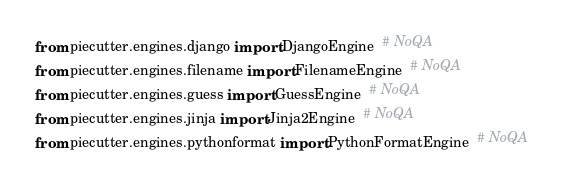Convert code to text. <code><loc_0><loc_0><loc_500><loc_500><_Python_>from piecutter.engines.django import DjangoEngine  # NoQA
from piecutter.engines.filename import FilenameEngine  # NoQA
from piecutter.engines.guess import GuessEngine  # NoQA
from piecutter.engines.jinja import Jinja2Engine  # NoQA
from piecutter.engines.pythonformat import PythonFormatEngine  # NoQA
</code> 